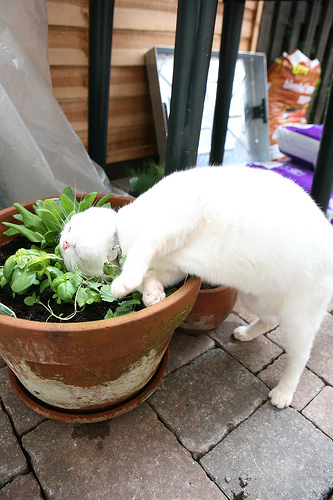What color does the tray in the top have? The tray at the top appears to be silver in color. 